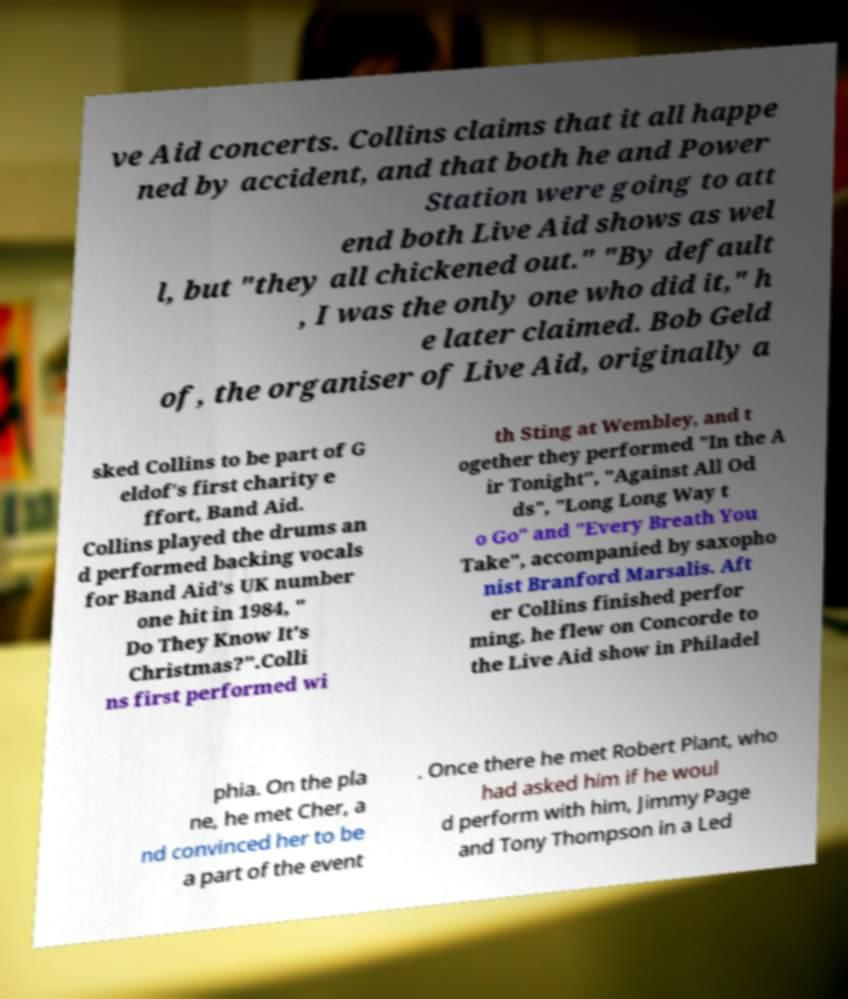Could you assist in decoding the text presented in this image and type it out clearly? ve Aid concerts. Collins claims that it all happe ned by accident, and that both he and Power Station were going to att end both Live Aid shows as wel l, but "they all chickened out." "By default , I was the only one who did it," h e later claimed. Bob Geld of, the organiser of Live Aid, originally a sked Collins to be part of G eldof's first charity e ffort, Band Aid. Collins played the drums an d performed backing vocals for Band Aid's UK number one hit in 1984, " Do They Know It's Christmas?".Colli ns first performed wi th Sting at Wembley, and t ogether they performed "In the A ir Tonight", "Against All Od ds", "Long Long Way t o Go" and "Every Breath You Take", accompanied by saxopho nist Branford Marsalis. Aft er Collins finished perfor ming, he flew on Concorde to the Live Aid show in Philadel phia. On the pla ne, he met Cher, a nd convinced her to be a part of the event . Once there he met Robert Plant, who had asked him if he woul d perform with him, Jimmy Page and Tony Thompson in a Led 